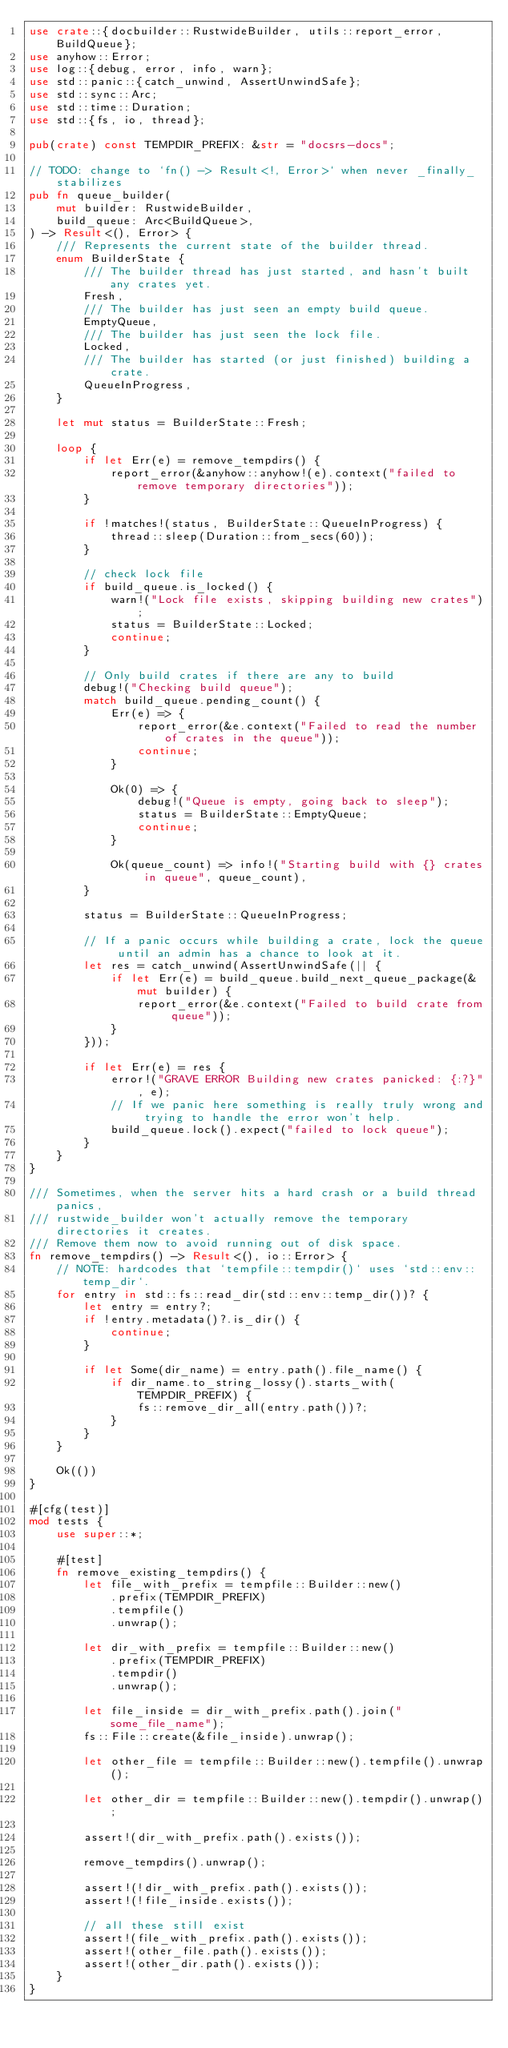<code> <loc_0><loc_0><loc_500><loc_500><_Rust_>use crate::{docbuilder::RustwideBuilder, utils::report_error, BuildQueue};
use anyhow::Error;
use log::{debug, error, info, warn};
use std::panic::{catch_unwind, AssertUnwindSafe};
use std::sync::Arc;
use std::time::Duration;
use std::{fs, io, thread};

pub(crate) const TEMPDIR_PREFIX: &str = "docsrs-docs";

// TODO: change to `fn() -> Result<!, Error>` when never _finally_ stabilizes
pub fn queue_builder(
    mut builder: RustwideBuilder,
    build_queue: Arc<BuildQueue>,
) -> Result<(), Error> {
    /// Represents the current state of the builder thread.
    enum BuilderState {
        /// The builder thread has just started, and hasn't built any crates yet.
        Fresh,
        /// The builder has just seen an empty build queue.
        EmptyQueue,
        /// The builder has just seen the lock file.
        Locked,
        /// The builder has started (or just finished) building a crate.
        QueueInProgress,
    }

    let mut status = BuilderState::Fresh;

    loop {
        if let Err(e) = remove_tempdirs() {
            report_error(&anyhow::anyhow!(e).context("failed to remove temporary directories"));
        }

        if !matches!(status, BuilderState::QueueInProgress) {
            thread::sleep(Duration::from_secs(60));
        }

        // check lock file
        if build_queue.is_locked() {
            warn!("Lock file exists, skipping building new crates");
            status = BuilderState::Locked;
            continue;
        }

        // Only build crates if there are any to build
        debug!("Checking build queue");
        match build_queue.pending_count() {
            Err(e) => {
                report_error(&e.context("Failed to read the number of crates in the queue"));
                continue;
            }

            Ok(0) => {
                debug!("Queue is empty, going back to sleep");
                status = BuilderState::EmptyQueue;
                continue;
            }

            Ok(queue_count) => info!("Starting build with {} crates in queue", queue_count),
        }

        status = BuilderState::QueueInProgress;

        // If a panic occurs while building a crate, lock the queue until an admin has a chance to look at it.
        let res = catch_unwind(AssertUnwindSafe(|| {
            if let Err(e) = build_queue.build_next_queue_package(&mut builder) {
                report_error(&e.context("Failed to build crate from queue"));
            }
        }));

        if let Err(e) = res {
            error!("GRAVE ERROR Building new crates panicked: {:?}", e);
            // If we panic here something is really truly wrong and trying to handle the error won't help.
            build_queue.lock().expect("failed to lock queue");
        }
    }
}

/// Sometimes, when the server hits a hard crash or a build thread panics,
/// rustwide_builder won't actually remove the temporary directories it creates.
/// Remove them now to avoid running out of disk space.
fn remove_tempdirs() -> Result<(), io::Error> {
    // NOTE: hardcodes that `tempfile::tempdir()` uses `std::env::temp_dir`.
    for entry in std::fs::read_dir(std::env::temp_dir())? {
        let entry = entry?;
        if !entry.metadata()?.is_dir() {
            continue;
        }

        if let Some(dir_name) = entry.path().file_name() {
            if dir_name.to_string_lossy().starts_with(TEMPDIR_PREFIX) {
                fs::remove_dir_all(entry.path())?;
            }
        }
    }

    Ok(())
}

#[cfg(test)]
mod tests {
    use super::*;

    #[test]
    fn remove_existing_tempdirs() {
        let file_with_prefix = tempfile::Builder::new()
            .prefix(TEMPDIR_PREFIX)
            .tempfile()
            .unwrap();

        let dir_with_prefix = tempfile::Builder::new()
            .prefix(TEMPDIR_PREFIX)
            .tempdir()
            .unwrap();

        let file_inside = dir_with_prefix.path().join("some_file_name");
        fs::File::create(&file_inside).unwrap();

        let other_file = tempfile::Builder::new().tempfile().unwrap();

        let other_dir = tempfile::Builder::new().tempdir().unwrap();

        assert!(dir_with_prefix.path().exists());

        remove_tempdirs().unwrap();

        assert!(!dir_with_prefix.path().exists());
        assert!(!file_inside.exists());

        // all these still exist
        assert!(file_with_prefix.path().exists());
        assert!(other_file.path().exists());
        assert!(other_dir.path().exists());
    }
}
</code> 